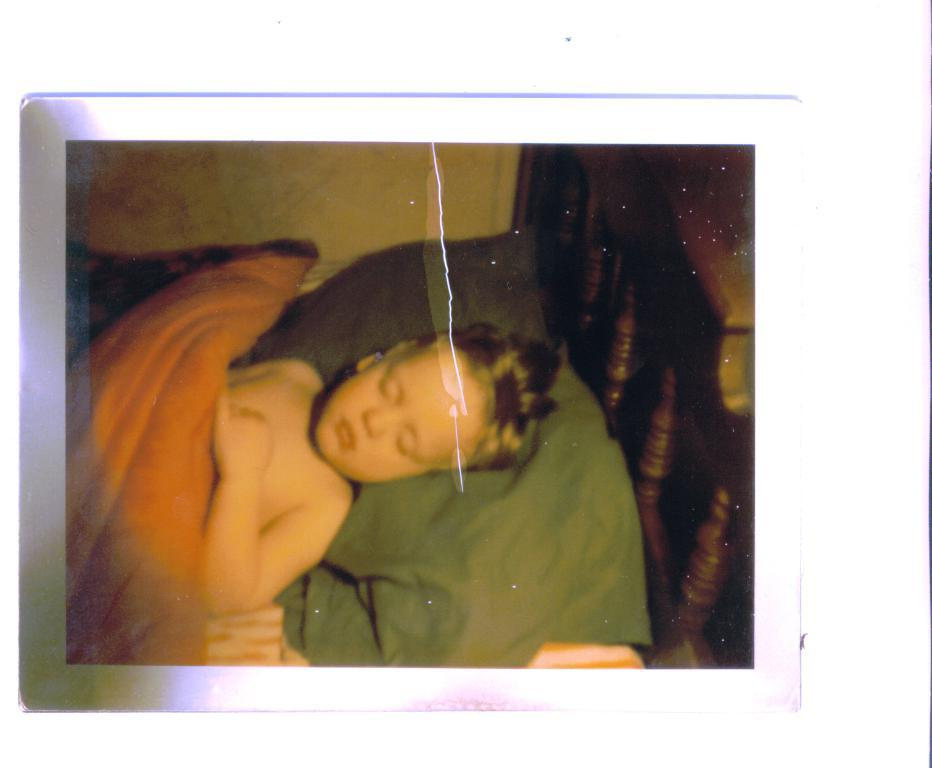What type of object is depicted in the image? The image appears to be a photo frame. Who or what is the main subject of the photo frame? There is a boy in the image. What is the boy doing in the image? The boy is lying on a bed. What type of texture can be seen on the flower in the image? There is no flower present in the image; it features a boy lying on a bed in a photo frame. 